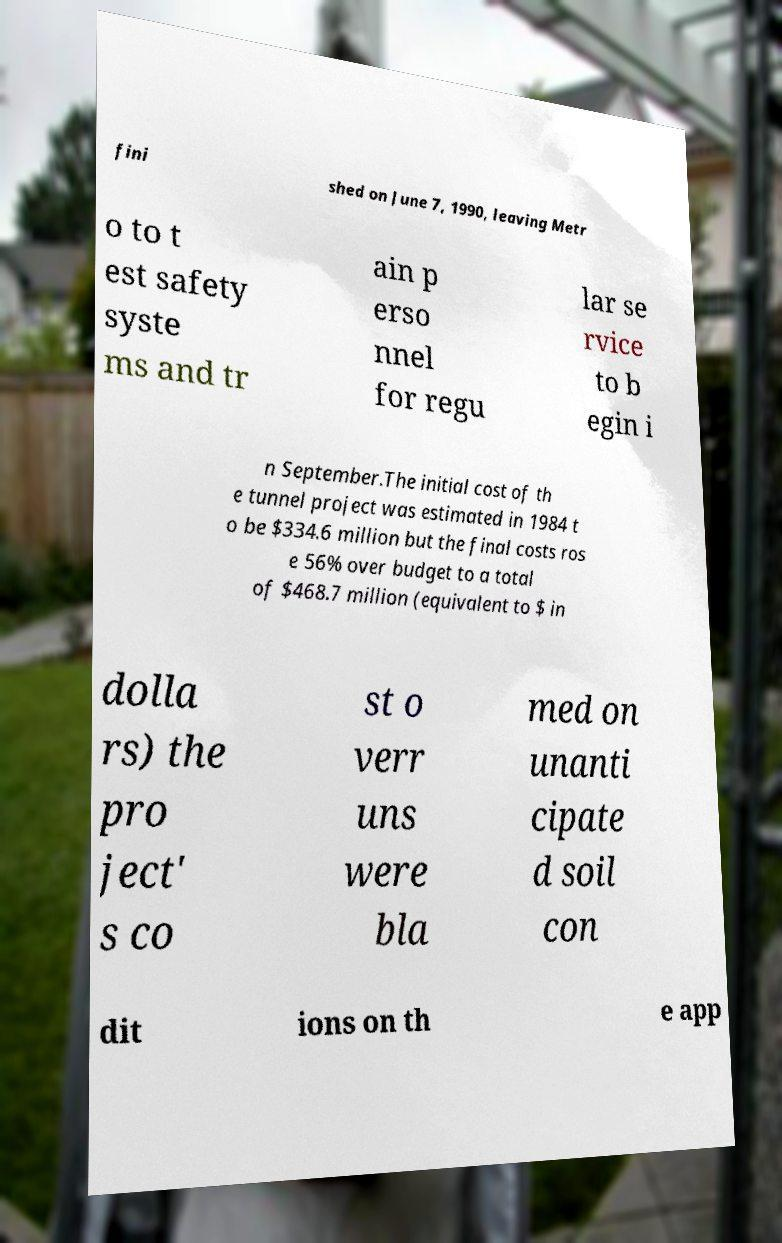For documentation purposes, I need the text within this image transcribed. Could you provide that? fini shed on June 7, 1990, leaving Metr o to t est safety syste ms and tr ain p erso nnel for regu lar se rvice to b egin i n September.The initial cost of th e tunnel project was estimated in 1984 t o be $334.6 million but the final costs ros e 56% over budget to a total of $468.7 million (equivalent to $ in dolla rs) the pro ject' s co st o verr uns were bla med on unanti cipate d soil con dit ions on th e app 